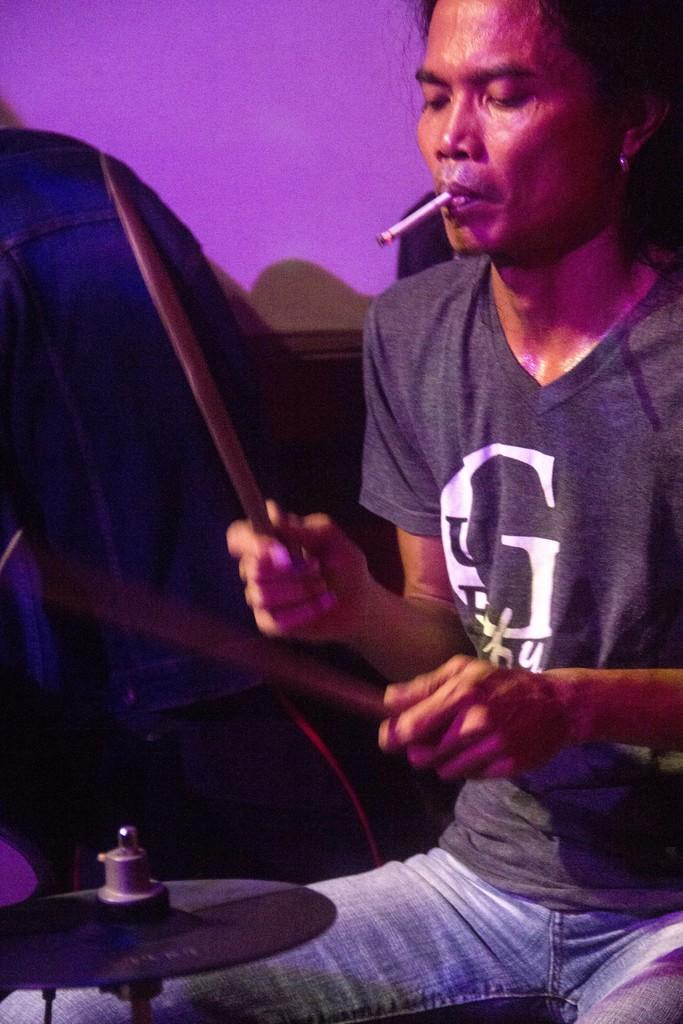<image>
Give a short and clear explanation of the subsequent image. a man playing the drums with a G on his shirt 